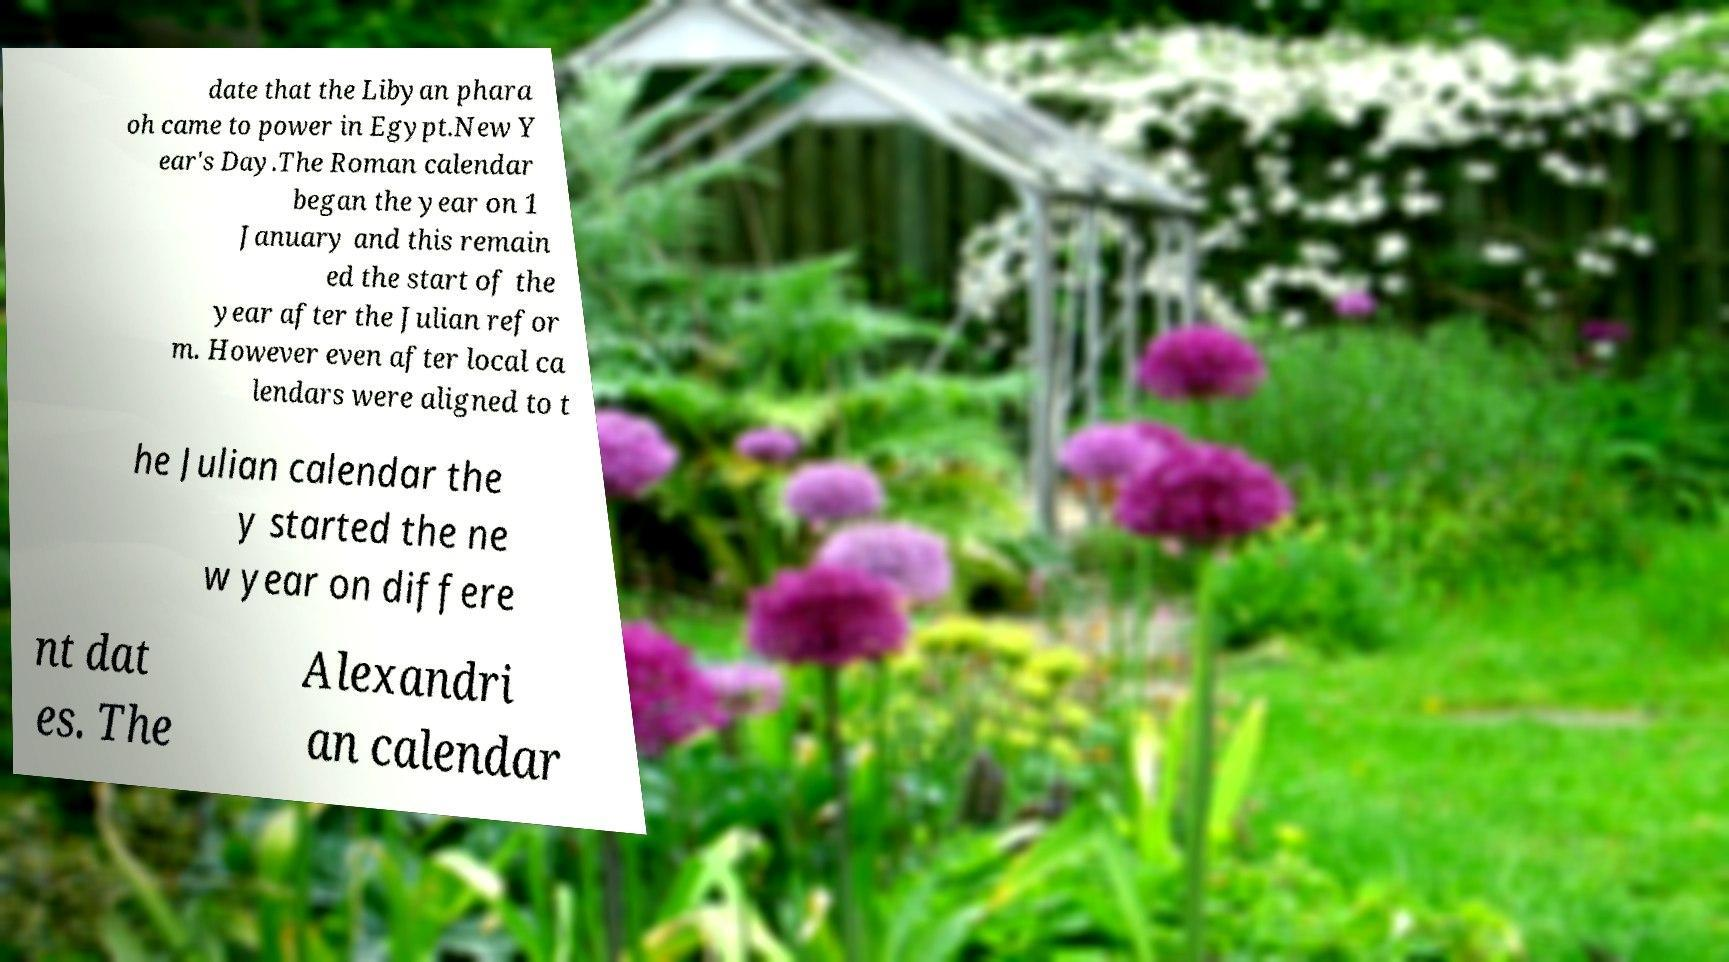What messages or text are displayed in this image? I need them in a readable, typed format. date that the Libyan phara oh came to power in Egypt.New Y ear's Day.The Roman calendar began the year on 1 January and this remain ed the start of the year after the Julian refor m. However even after local ca lendars were aligned to t he Julian calendar the y started the ne w year on differe nt dat es. The Alexandri an calendar 